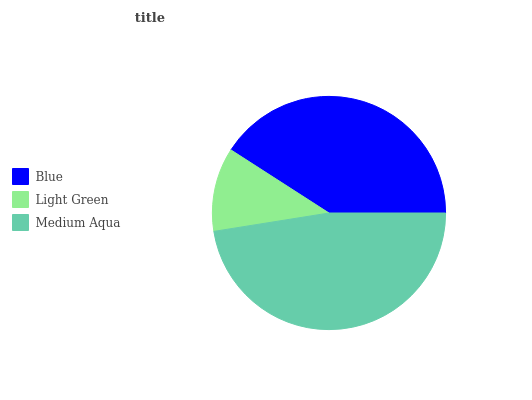Is Light Green the minimum?
Answer yes or no. Yes. Is Medium Aqua the maximum?
Answer yes or no. Yes. Is Medium Aqua the minimum?
Answer yes or no. No. Is Light Green the maximum?
Answer yes or no. No. Is Medium Aqua greater than Light Green?
Answer yes or no. Yes. Is Light Green less than Medium Aqua?
Answer yes or no. Yes. Is Light Green greater than Medium Aqua?
Answer yes or no. No. Is Medium Aqua less than Light Green?
Answer yes or no. No. Is Blue the high median?
Answer yes or no. Yes. Is Blue the low median?
Answer yes or no. Yes. Is Medium Aqua the high median?
Answer yes or no. No. Is Light Green the low median?
Answer yes or no. No. 